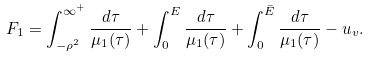Convert formula to latex. <formula><loc_0><loc_0><loc_500><loc_500>F _ { 1 } = \int _ { - \rho ^ { 2 } } ^ { \infty ^ { + } } \frac { d \tau } { \mu _ { 1 } ( \tau ) } + \int _ { 0 } ^ { E } \frac { d \tau } { \mu _ { 1 } ( \tau ) } + \int _ { 0 } ^ { \bar { E } } \frac { d \tau } { \mu _ { 1 } ( \tau ) } - u _ { v } .</formula> 